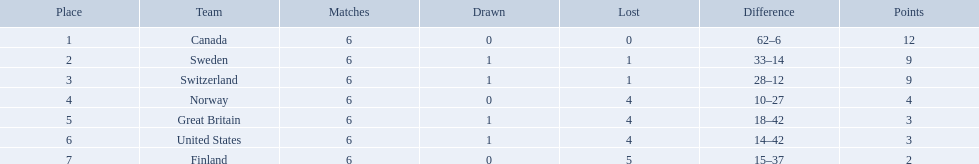What are all the teams? Canada, Sweden, Switzerland, Norway, Great Britain, United States, Finland. What were their points? 12, 9, 9, 4, 3, 3, 2. What about just switzerland and great britain? 9, 3. Now, which of those teams scored higher? Switzerland. 